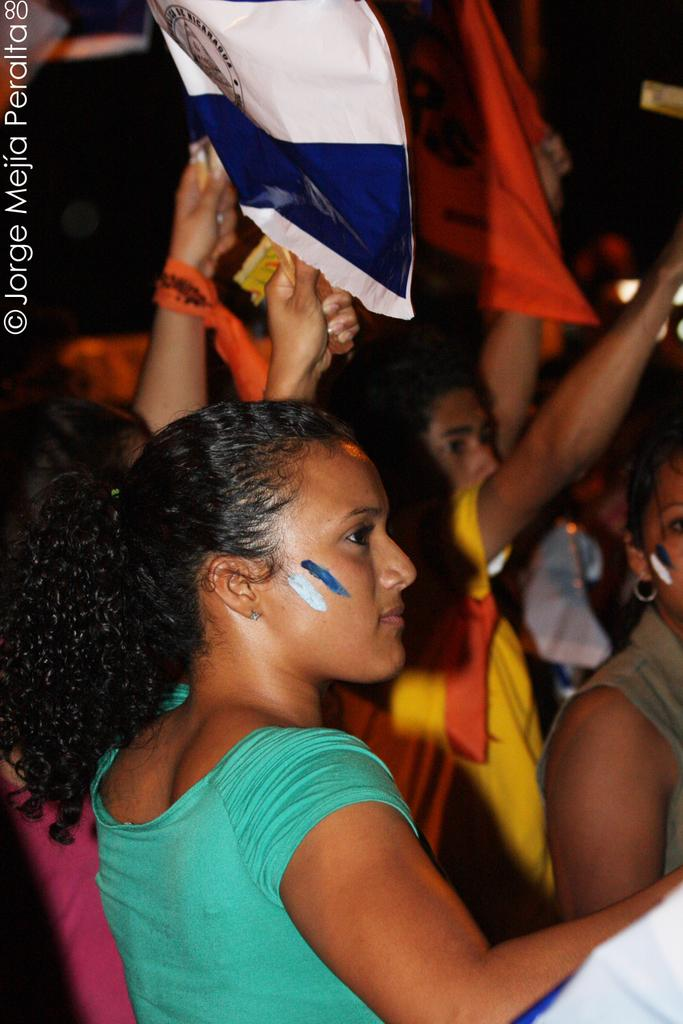What is the woman in the image wearing? The woman is wearing a green t-shirt in the image. What is the woman doing in the image? The woman is standing in a protest in the image. What is the woman holding in her hand? The woman is holding a white cover in her hand. How many girls are standing behind the woman in the image? There are many girls standing behind the woman in the image. What type of toys can be seen in the image? There are no toys present in the image. Is there a volcano visible in the background of the image? There is no volcano visible in the image. 